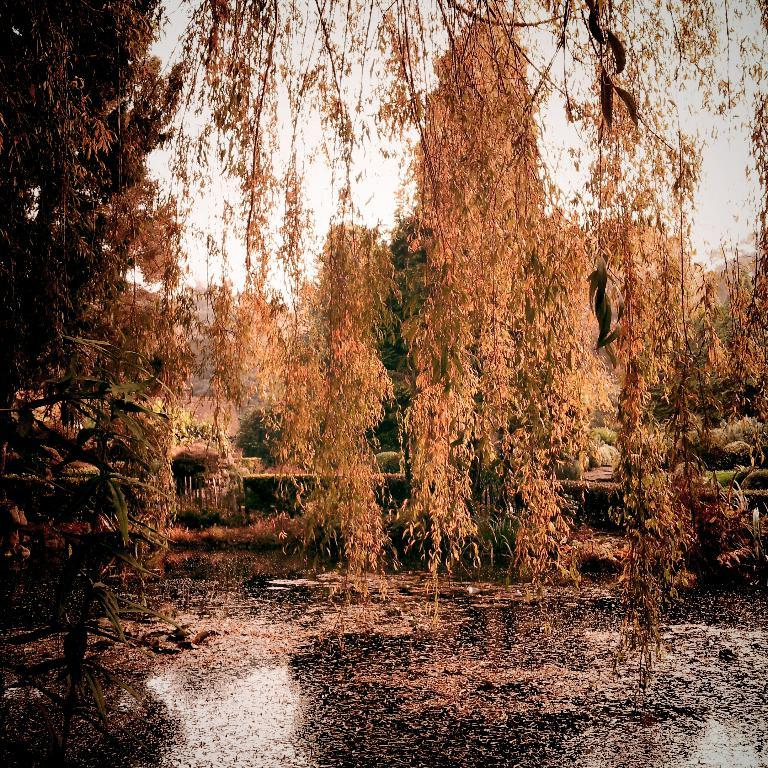What is floating on the water in the image? There are leaves on the water in the image. What type of vegetation is present in the image? There are trees in the image. What can be seen in the background of the image? The sky is visible in the background of the image. Where is the toad sitting in the image? There is no toad present in the image. What type of patch can be seen on the leaves in the image? There are no patches visible on the leaves in the image. 